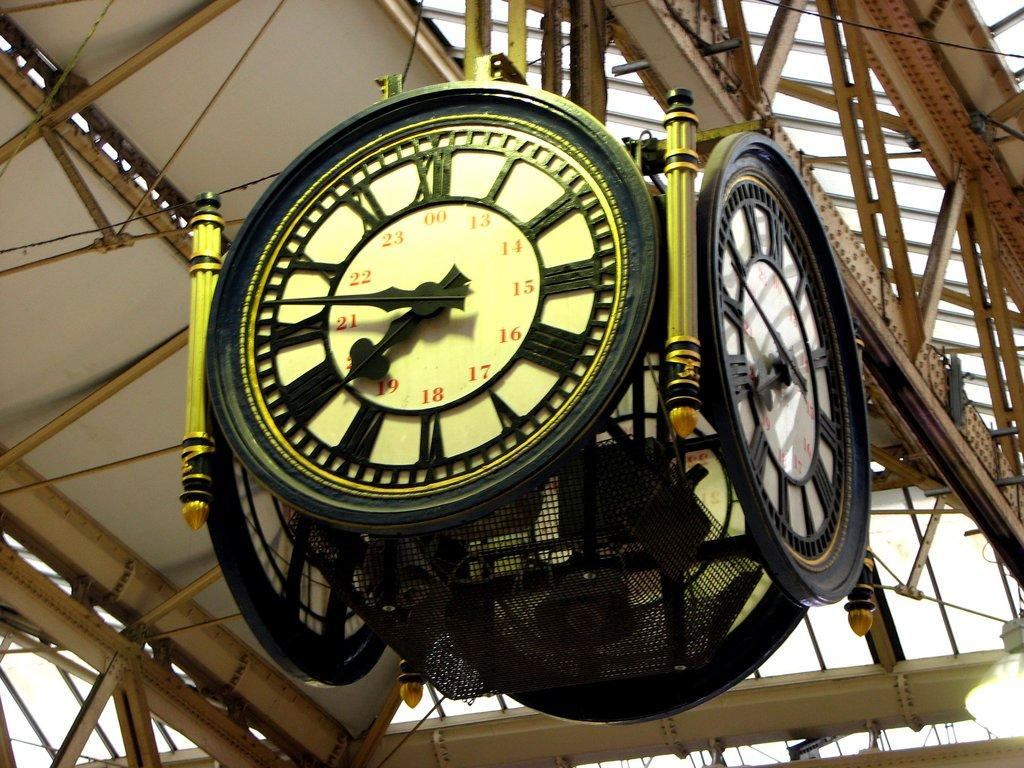<image>
Describe the image concisely. four sided clock hanging from roof showing time of 7:47 